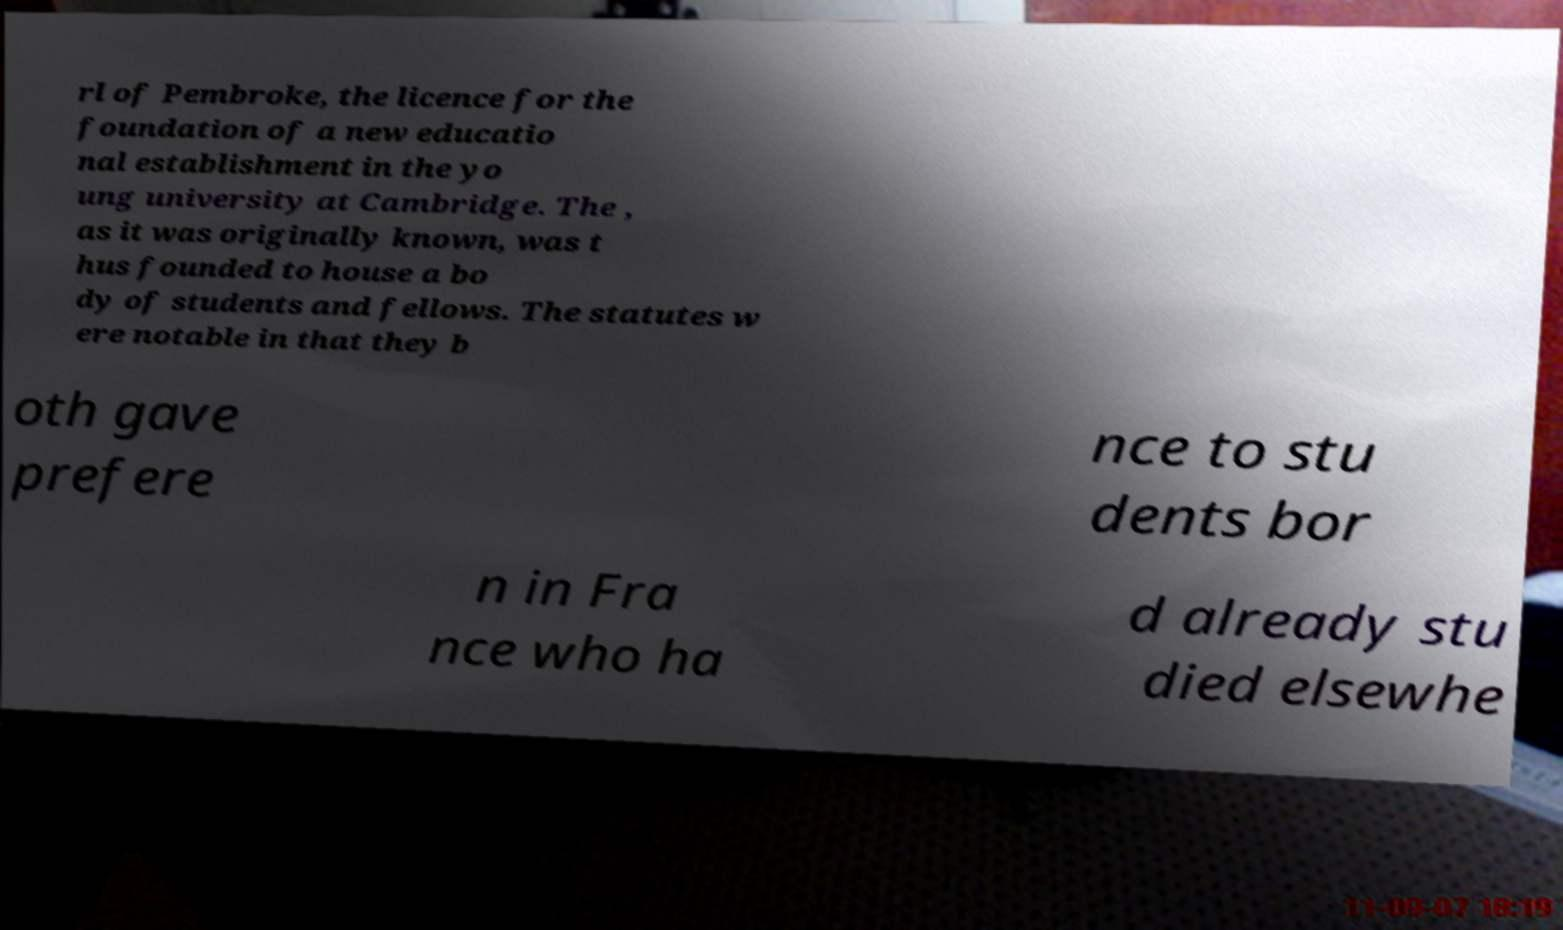I need the written content from this picture converted into text. Can you do that? rl of Pembroke, the licence for the foundation of a new educatio nal establishment in the yo ung university at Cambridge. The , as it was originally known, was t hus founded to house a bo dy of students and fellows. The statutes w ere notable in that they b oth gave prefere nce to stu dents bor n in Fra nce who ha d already stu died elsewhe 